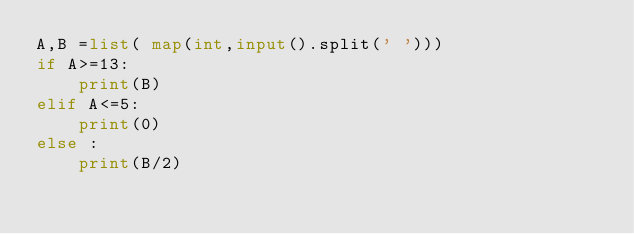Convert code to text. <code><loc_0><loc_0><loc_500><loc_500><_Python_>A,B =list( map(int,input().split(' ')))
if A>=13:
    print(B)
elif A<=5:
    print(0)
else :
    print(B/2)
</code> 